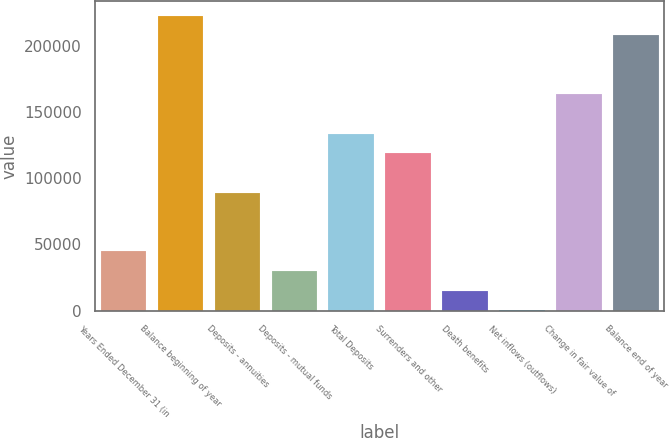<chart> <loc_0><loc_0><loc_500><loc_500><bar_chart><fcel>Years Ended December 31 (in<fcel>Balance beginning of year<fcel>Deposits - annuities<fcel>Deposits - mutual funds<fcel>Total Deposits<fcel>Surrenders and other<fcel>Death benefits<fcel>Net inflows (outflows)<fcel>Change in fair value of<fcel>Balance end of year<nl><fcel>44729.9<fcel>222682<fcel>89217.8<fcel>29900.6<fcel>133706<fcel>118876<fcel>15071.3<fcel>242<fcel>163364<fcel>207852<nl></chart> 